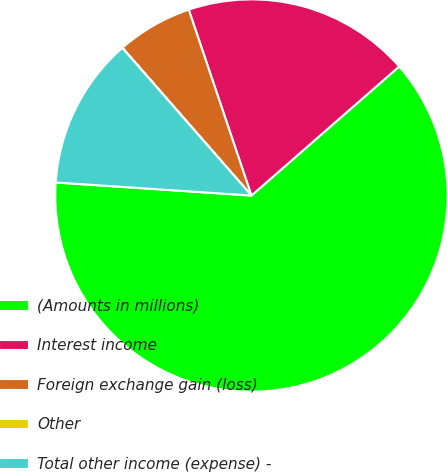Convert chart. <chart><loc_0><loc_0><loc_500><loc_500><pie_chart><fcel>(Amounts in millions)<fcel>Interest income<fcel>Foreign exchange gain (loss)<fcel>Other<fcel>Total other income (expense) -<nl><fcel>62.49%<fcel>18.75%<fcel>6.25%<fcel>0.01%<fcel>12.5%<nl></chart> 